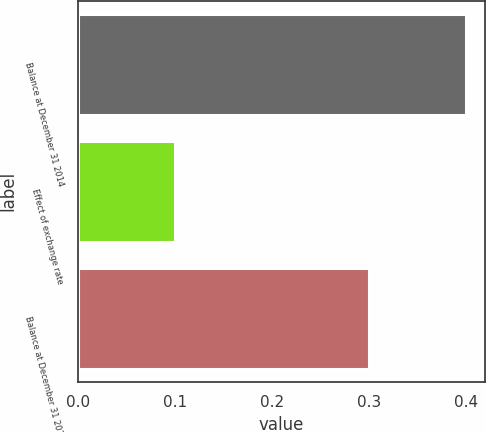<chart> <loc_0><loc_0><loc_500><loc_500><bar_chart><fcel>Balance at December 31 2014<fcel>Effect of exchange rate<fcel>Balance at December 31 2015<nl><fcel>0.4<fcel>0.1<fcel>0.3<nl></chart> 